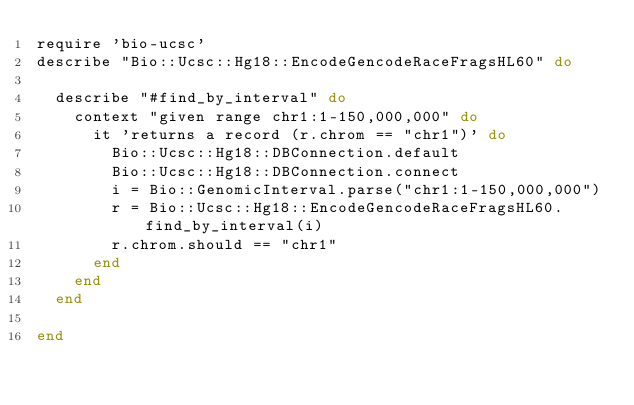Convert code to text. <code><loc_0><loc_0><loc_500><loc_500><_Ruby_>require 'bio-ucsc'
describe "Bio::Ucsc::Hg18::EncodeGencodeRaceFragsHL60" do 

  describe "#find_by_interval" do
    context "given range chr1:1-150,000,000" do
      it 'returns a record (r.chrom == "chr1")' do
        Bio::Ucsc::Hg18::DBConnection.default
        Bio::Ucsc::Hg18::DBConnection.connect
        i = Bio::GenomicInterval.parse("chr1:1-150,000,000")
        r = Bio::Ucsc::Hg18::EncodeGencodeRaceFragsHL60.find_by_interval(i)
        r.chrom.should == "chr1"
      end
    end
  end

end
</code> 